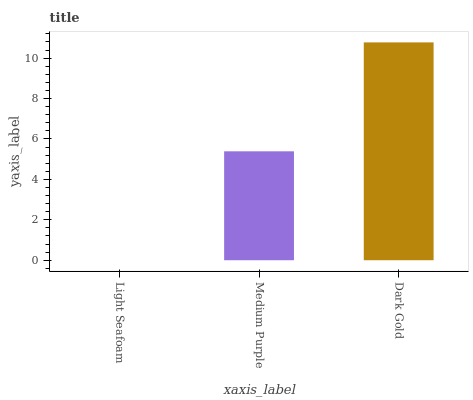Is Medium Purple the minimum?
Answer yes or no. No. Is Medium Purple the maximum?
Answer yes or no. No. Is Medium Purple greater than Light Seafoam?
Answer yes or no. Yes. Is Light Seafoam less than Medium Purple?
Answer yes or no. Yes. Is Light Seafoam greater than Medium Purple?
Answer yes or no. No. Is Medium Purple less than Light Seafoam?
Answer yes or no. No. Is Medium Purple the high median?
Answer yes or no. Yes. Is Medium Purple the low median?
Answer yes or no. Yes. Is Dark Gold the high median?
Answer yes or no. No. Is Dark Gold the low median?
Answer yes or no. No. 